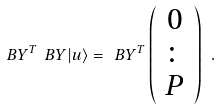<formula> <loc_0><loc_0><loc_500><loc_500>\ B Y ^ { T } \ B Y | u \rangle = \ B Y ^ { T } \left ( \begin{array} { c } 0 \\ \colon \\ P \\ \end{array} \right ) \ .</formula> 